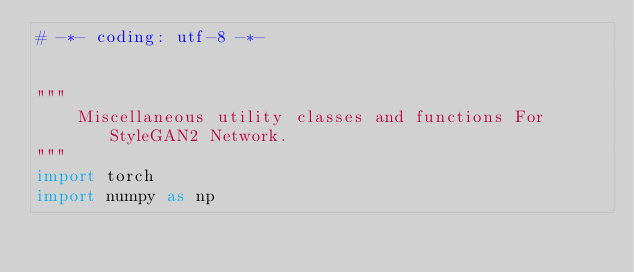<code> <loc_0><loc_0><loc_500><loc_500><_Python_># -*- coding: utf-8 -*-


"""
    Miscellaneous utility classes and functions For StyleGAN2 Network.
"""
import torch
import numpy as np

</code> 